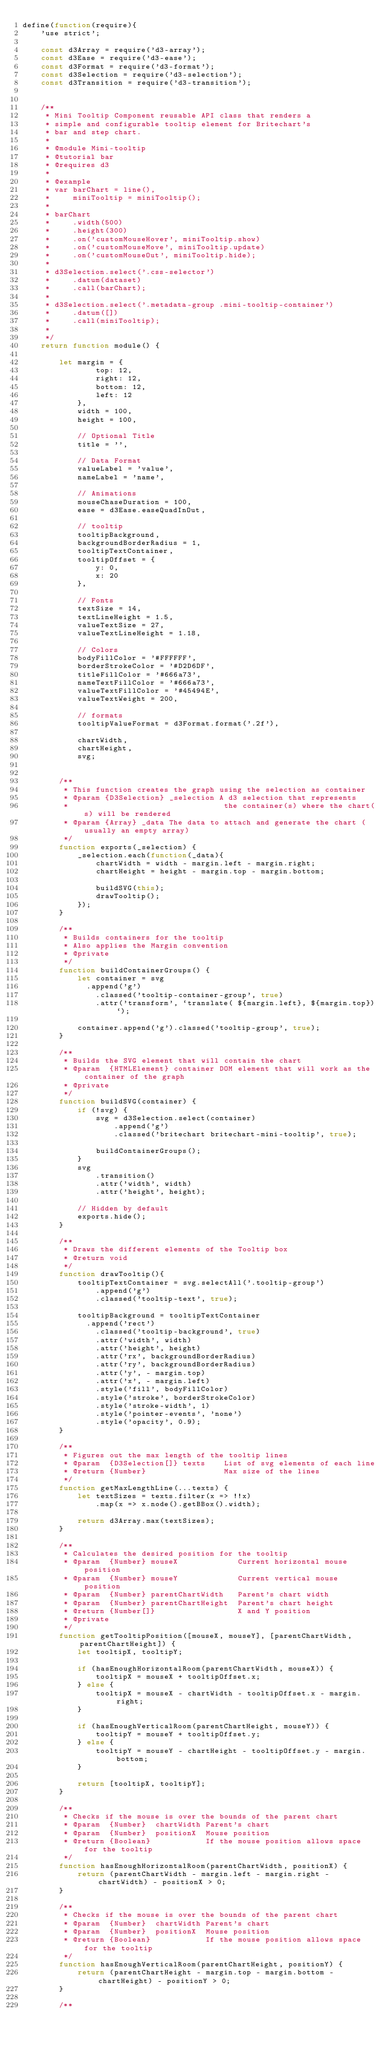<code> <loc_0><loc_0><loc_500><loc_500><_JavaScript_>define(function(require){
    'use strict';

    const d3Array = require('d3-array');
    const d3Ease = require('d3-ease');
    const d3Format = require('d3-format');
    const d3Selection = require('d3-selection');
    const d3Transition = require('d3-transition');


    /**
     * Mini Tooltip Component reusable API class that renders a
     * simple and configurable tooltip element for Britechart's
     * bar and step chart.
     *
     * @module Mini-tooltip
     * @tutorial bar
     * @requires d3
     *
     * @example
     * var barChart = line(),
     *     miniTooltip = miniTooltip();
     *
     * barChart
     *     .width(500)
     *     .height(300)
     *     .on('customMouseHover', miniTooltip.show)
     *     .on('customMouseMove', miniTooltip.update)
     *     .on('customMouseOut', miniTooltip.hide);
     *
     * d3Selection.select('.css-selector')
     *     .datum(dataset)
     *     .call(barChart);
     *
     * d3Selection.select('.metadata-group .mini-tooltip-container')
     *     .datum([])
     *     .call(miniTooltip);
     *
     */
    return function module() {

        let margin = {
                top: 12,
                right: 12,
                bottom: 12,
                left: 12
            },
            width = 100,
            height = 100,

            // Optional Title
            title = '',

            // Data Format
            valueLabel = 'value',
            nameLabel = 'name',

            // Animations
            mouseChaseDuration = 100,
            ease = d3Ease.easeQuadInOut,

            // tooltip
            tooltipBackground,
            backgroundBorderRadius = 1,
            tooltipTextContainer,
            tooltipOffset = {
                y: 0,
                x: 20
            },

            // Fonts
            textSize = 14,
            textLineHeight = 1.5,
            valueTextSize = 27,
            valueTextLineHeight = 1.18,

            // Colors
            bodyFillColor = '#FFFFFF',
            borderStrokeColor = '#D2D6DF',
            titleFillColor = '#666a73',
            nameTextFillColor = '#666a73',
            valueTextFillColor = '#45494E',
            valueTextWeight = 200,

            // formats
            tooltipValueFormat = d3Format.format('.2f'),

            chartWidth,
            chartHeight,
            svg;


        /**
         * This function creates the graph using the selection as container
         * @param {D3Selection} _selection A d3 selection that represents
         *                                  the container(s) where the chart(s) will be rendered
         * @param {Array} _data The data to attach and generate the chart (usually an empty array)
         */
        function exports(_selection) {
            _selection.each(function(_data){
                chartWidth = width - margin.left - margin.right;
                chartHeight = height - margin.top - margin.bottom;

                buildSVG(this);
                drawTooltip();
            });
        }

        /**
         * Builds containers for the tooltip
         * Also applies the Margin convention
         * @private
         */
        function buildContainerGroups() {
            let container = svg
              .append('g')
                .classed('tooltip-container-group', true)
                .attr('transform', `translate( ${margin.left}, ${margin.top})`);

            container.append('g').classed('tooltip-group', true);
        }

        /**
         * Builds the SVG element that will contain the chart
         * @param  {HTMLElement} container DOM element that will work as the container of the graph
         * @private
         */
        function buildSVG(container) {
            if (!svg) {
                svg = d3Selection.select(container)
                    .append('g')
                    .classed('britechart britechart-mini-tooltip', true);

                buildContainerGroups();
            }
            svg
                .transition()
                .attr('width', width)
                .attr('height', height);

            // Hidden by default
            exports.hide();
        }

        /**
         * Draws the different elements of the Tooltip box
         * @return void
         */
        function drawTooltip(){
            tooltipTextContainer = svg.selectAll('.tooltip-group')
                .append('g')
                .classed('tooltip-text', true);

            tooltipBackground = tooltipTextContainer
              .append('rect')
                .classed('tooltip-background', true)
                .attr('width', width)
                .attr('height', height)
                .attr('rx', backgroundBorderRadius)
                .attr('ry', backgroundBorderRadius)
                .attr('y', - margin.top)
                .attr('x', - margin.left)
                .style('fill', bodyFillColor)
                .style('stroke', borderStrokeColor)
                .style('stroke-width', 1)
                .style('pointer-events', 'none')
                .style('opacity', 0.9);
        }

        /**
         * Figures out the max length of the tooltip lines
         * @param  {D3Selection[]} texts    List of svg elements of each line
         * @return {Number}                 Max size of the lines
         */
        function getMaxLengthLine(...texts) {
            let textSizes = texts.filter(x => !!x)
                .map(x => x.node().getBBox().width);

            return d3Array.max(textSizes);
        }

        /**
         * Calculates the desired position for the tooltip
         * @param  {Number} mouseX             Current horizontal mouse position
         * @param  {Number} mouseY             Current vertical mouse position
         * @param  {Number} parentChartWidth   Parent's chart width
         * @param  {Number} parentChartHeight  Parent's chart height
         * @return {Number[]}                  X and Y position
         * @private
         */
        function getTooltipPosition([mouseX, mouseY], [parentChartWidth, parentChartHeight]) {
            let tooltipX, tooltipY;

            if (hasEnoughHorizontalRoom(parentChartWidth, mouseX)) {
                tooltipX = mouseX + tooltipOffset.x;
            } else {
                tooltipX = mouseX - chartWidth - tooltipOffset.x - margin.right;
            }

            if (hasEnoughVerticalRoom(parentChartHeight, mouseY)) {
                tooltipY = mouseY + tooltipOffset.y;
            } else {
                tooltipY = mouseY - chartHeight - tooltipOffset.y - margin.bottom;
            }

            return [tooltipX, tooltipY];
        }

        /**
         * Checks if the mouse is over the bounds of the parent chart
         * @param  {Number}  chartWidth Parent's chart
         * @param  {Number}  positionX  Mouse position
         * @return {Boolean}            If the mouse position allows space for the tooltip
         */
        function hasEnoughHorizontalRoom(parentChartWidth, positionX) {
            return (parentChartWidth - margin.left - margin.right - chartWidth) - positionX > 0;
        }

        /**
         * Checks if the mouse is over the bounds of the parent chart
         * @param  {Number}  chartWidth Parent's chart
         * @param  {Number}  positionX  Mouse position
         * @return {Boolean}            If the mouse position allows space for the tooltip
         */
        function hasEnoughVerticalRoom(parentChartHeight, positionY) {
            return (parentChartHeight - margin.top - margin.bottom - chartHeight) - positionY > 0;
        }

        /**</code> 